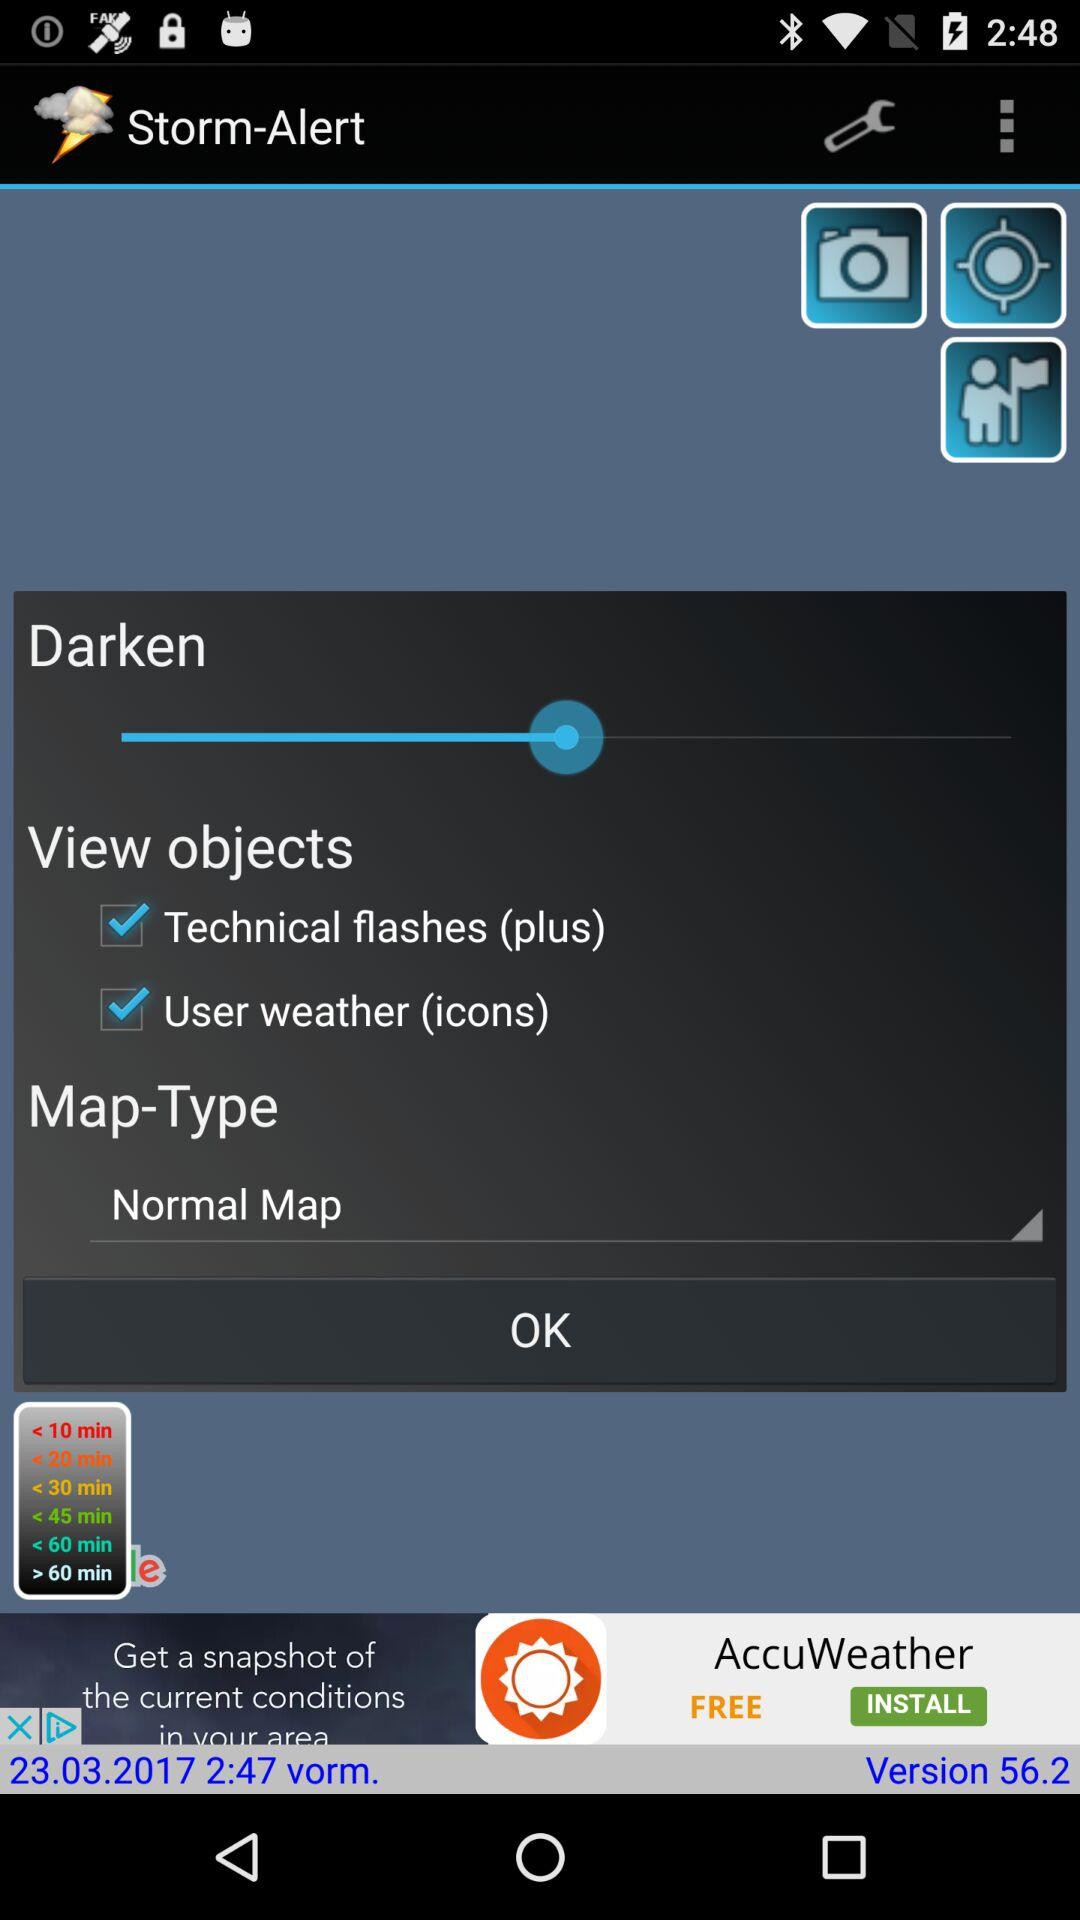What is the version of the application? The version of the application is 56.2. 